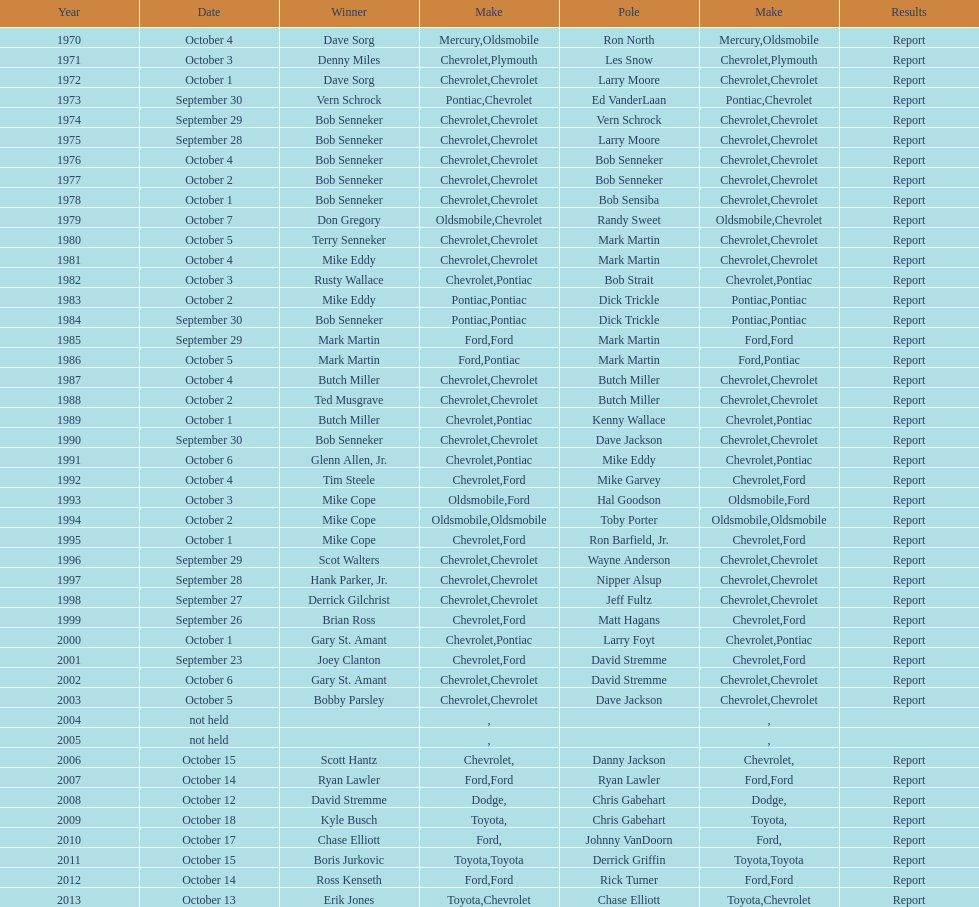Who on the list has the highest number of consecutive wins? Bob Senneker. 